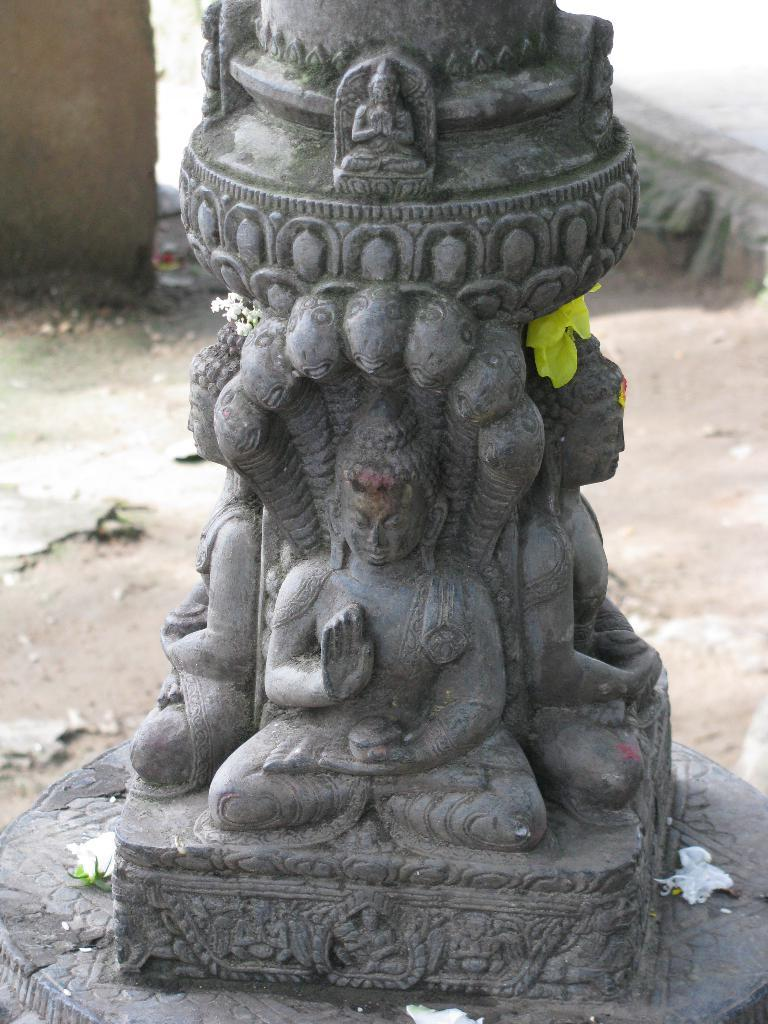What is the main structure in the image? There is a pillar in the image. What is on the pillar? There are god statues on the pillar. What color are the pillar and statues? The pillar and statues are in grey color. What type of flowers can be seen in the image? There are yellow and white color flowers in the image. What is happening in the scene behind the pillar? There is no scene visible behind the pillar in the image. How does the pillar aid in digestion? The pillar is not related to digestion; it is a structure with god statues on it. 